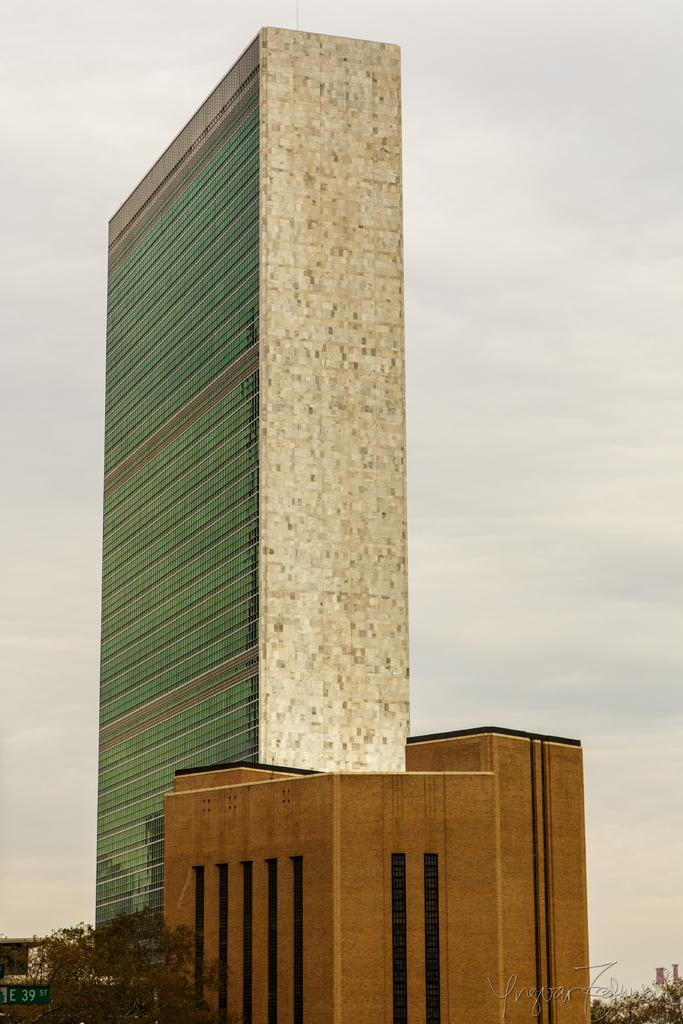What type of structures can be seen in the image? There are buildings in the image. What other natural elements are present in the image? There are trees in the image. Can you describe the object located at the bottom left of the image? There is a board at the bottom left of the image. What is visible at the top of the image? The sky is visible at the top of the image. What type of current can be seen flowing through the buildings in the image? There is no current flowing through the buildings in the image; it is a still image. Can you describe the fork that is being used to eat the trees in the image? There is no fork present in the image, and trees are not being eaten. 